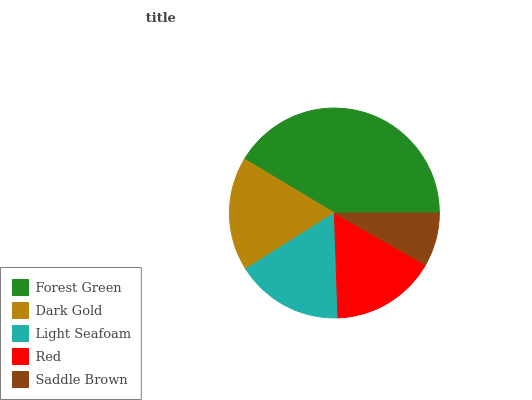Is Saddle Brown the minimum?
Answer yes or no. Yes. Is Forest Green the maximum?
Answer yes or no. Yes. Is Dark Gold the minimum?
Answer yes or no. No. Is Dark Gold the maximum?
Answer yes or no. No. Is Forest Green greater than Dark Gold?
Answer yes or no. Yes. Is Dark Gold less than Forest Green?
Answer yes or no. Yes. Is Dark Gold greater than Forest Green?
Answer yes or no. No. Is Forest Green less than Dark Gold?
Answer yes or no. No. Is Light Seafoam the high median?
Answer yes or no. Yes. Is Light Seafoam the low median?
Answer yes or no. Yes. Is Dark Gold the high median?
Answer yes or no. No. Is Red the low median?
Answer yes or no. No. 